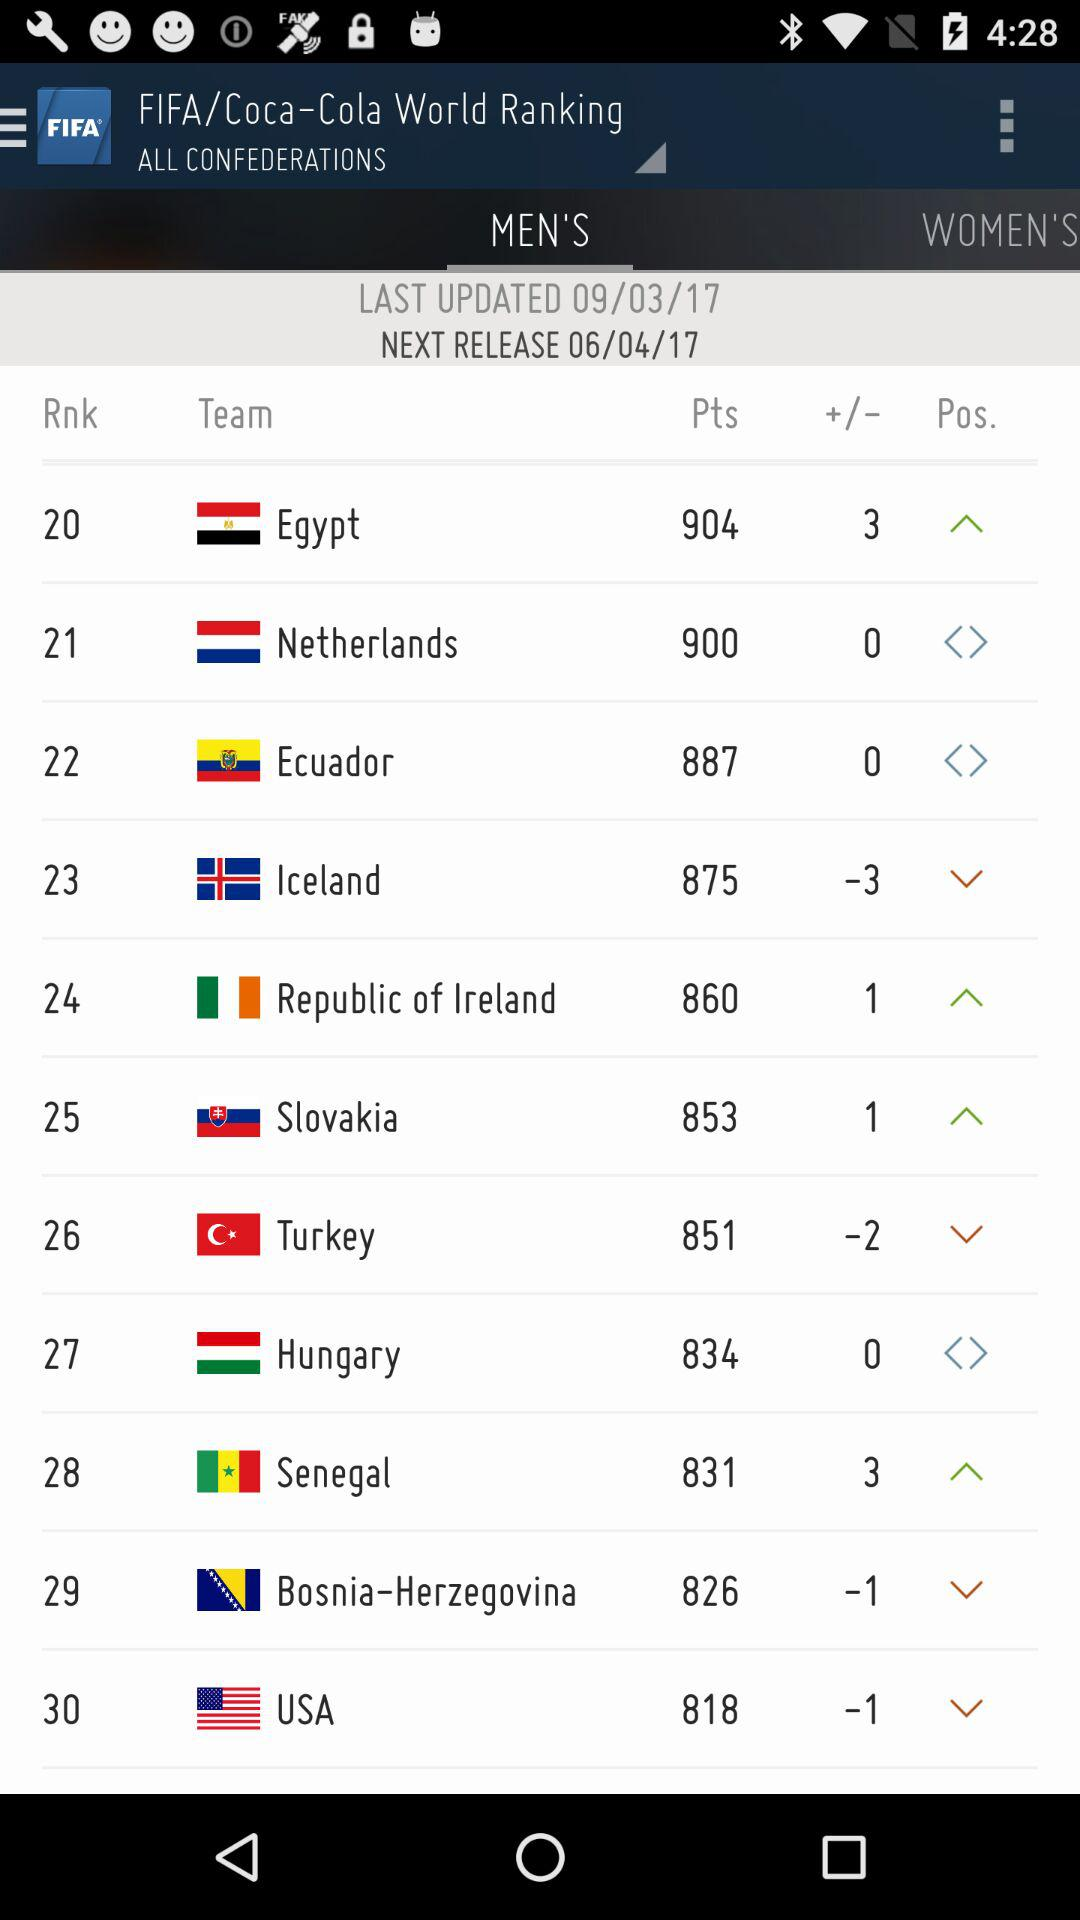What is the next release date? The next release date is June 4, 2017. 